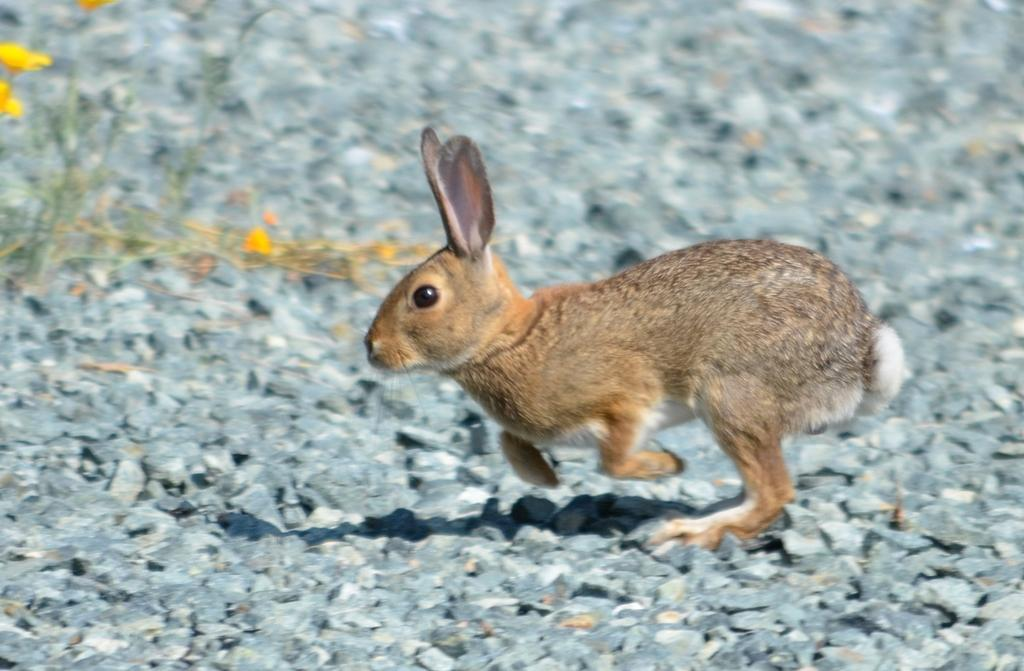What animal is present in the image? There is a rabbit in the image. What is the color of the rabbit? The rabbit is brown in color. Where is the rabbit located in the image? The rabbit is on the ground. What statement does the rabbit make in the image? The rabbit does not make any statements in the image, as it is an animal and cannot speak or make statements. 